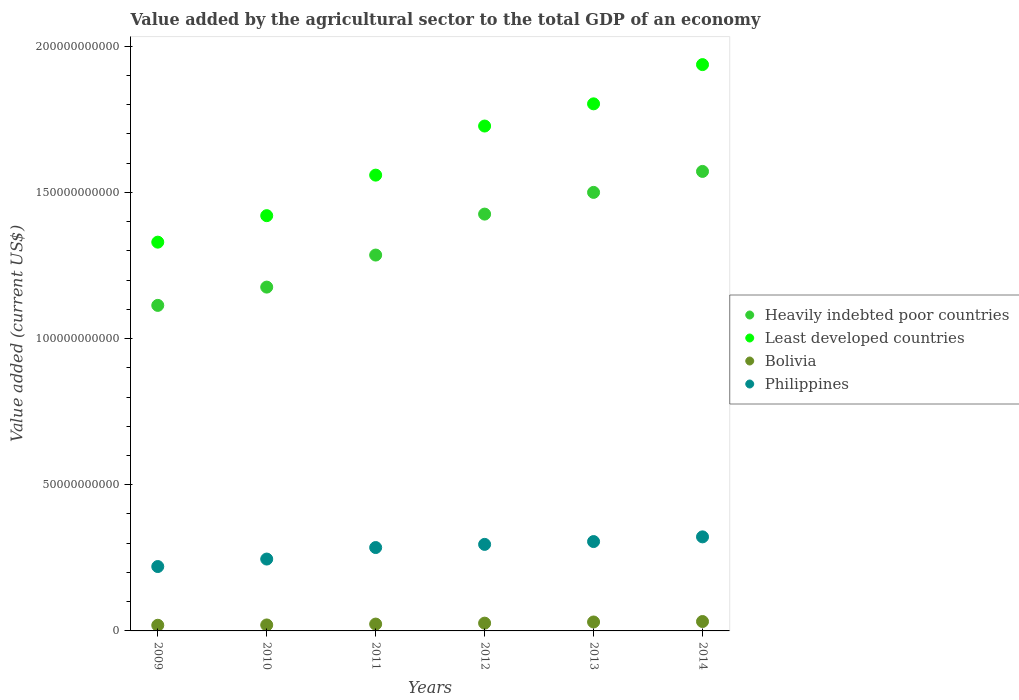How many different coloured dotlines are there?
Your response must be concise. 4. What is the value added by the agricultural sector to the total GDP in Bolivia in 2014?
Your response must be concise. 3.21e+09. Across all years, what is the maximum value added by the agricultural sector to the total GDP in Heavily indebted poor countries?
Your answer should be very brief. 1.57e+11. Across all years, what is the minimum value added by the agricultural sector to the total GDP in Bolivia?
Make the answer very short. 1.93e+09. In which year was the value added by the agricultural sector to the total GDP in Bolivia minimum?
Make the answer very short. 2009. What is the total value added by the agricultural sector to the total GDP in Bolivia in the graph?
Your answer should be very brief. 1.52e+1. What is the difference between the value added by the agricultural sector to the total GDP in Philippines in 2013 and that in 2014?
Keep it short and to the point. -1.61e+09. What is the difference between the value added by the agricultural sector to the total GDP in Heavily indebted poor countries in 2011 and the value added by the agricultural sector to the total GDP in Bolivia in 2012?
Your answer should be compact. 1.26e+11. What is the average value added by the agricultural sector to the total GDP in Heavily indebted poor countries per year?
Provide a short and direct response. 1.35e+11. In the year 2009, what is the difference between the value added by the agricultural sector to the total GDP in Least developed countries and value added by the agricultural sector to the total GDP in Heavily indebted poor countries?
Make the answer very short. 2.16e+1. In how many years, is the value added by the agricultural sector to the total GDP in Heavily indebted poor countries greater than 130000000000 US$?
Make the answer very short. 3. What is the ratio of the value added by the agricultural sector to the total GDP in Philippines in 2012 to that in 2014?
Offer a terse response. 0.92. Is the value added by the agricultural sector to the total GDP in Least developed countries in 2009 less than that in 2012?
Ensure brevity in your answer.  Yes. What is the difference between the highest and the second highest value added by the agricultural sector to the total GDP in Bolivia?
Provide a succinct answer. 1.58e+08. What is the difference between the highest and the lowest value added by the agricultural sector to the total GDP in Least developed countries?
Provide a succinct answer. 6.07e+1. Is it the case that in every year, the sum of the value added by the agricultural sector to the total GDP in Least developed countries and value added by the agricultural sector to the total GDP in Bolivia  is greater than the sum of value added by the agricultural sector to the total GDP in Heavily indebted poor countries and value added by the agricultural sector to the total GDP in Philippines?
Ensure brevity in your answer.  No. Is the value added by the agricultural sector to the total GDP in Least developed countries strictly greater than the value added by the agricultural sector to the total GDP in Heavily indebted poor countries over the years?
Ensure brevity in your answer.  Yes. Is the value added by the agricultural sector to the total GDP in Least developed countries strictly less than the value added by the agricultural sector to the total GDP in Philippines over the years?
Offer a very short reply. No. How many years are there in the graph?
Provide a short and direct response. 6. What is the difference between two consecutive major ticks on the Y-axis?
Give a very brief answer. 5.00e+1. Are the values on the major ticks of Y-axis written in scientific E-notation?
Provide a short and direct response. No. Does the graph contain any zero values?
Your response must be concise. No. How many legend labels are there?
Provide a short and direct response. 4. How are the legend labels stacked?
Offer a very short reply. Vertical. What is the title of the graph?
Offer a very short reply. Value added by the agricultural sector to the total GDP of an economy. Does "West Bank and Gaza" appear as one of the legend labels in the graph?
Offer a terse response. No. What is the label or title of the Y-axis?
Offer a very short reply. Value added (current US$). What is the Value added (current US$) in Heavily indebted poor countries in 2009?
Offer a terse response. 1.11e+11. What is the Value added (current US$) of Least developed countries in 2009?
Your response must be concise. 1.33e+11. What is the Value added (current US$) in Bolivia in 2009?
Give a very brief answer. 1.93e+09. What is the Value added (current US$) in Philippines in 2009?
Your answer should be compact. 2.20e+1. What is the Value added (current US$) in Heavily indebted poor countries in 2010?
Provide a succinct answer. 1.18e+11. What is the Value added (current US$) in Least developed countries in 2010?
Keep it short and to the point. 1.42e+11. What is the Value added (current US$) of Bolivia in 2010?
Provide a short and direct response. 2.04e+09. What is the Value added (current US$) in Philippines in 2010?
Your answer should be very brief. 2.46e+1. What is the Value added (current US$) of Heavily indebted poor countries in 2011?
Offer a very short reply. 1.29e+11. What is the Value added (current US$) of Least developed countries in 2011?
Your response must be concise. 1.56e+11. What is the Value added (current US$) of Bolivia in 2011?
Make the answer very short. 2.34e+09. What is the Value added (current US$) of Philippines in 2011?
Offer a terse response. 2.85e+1. What is the Value added (current US$) in Heavily indebted poor countries in 2012?
Keep it short and to the point. 1.43e+11. What is the Value added (current US$) of Least developed countries in 2012?
Provide a succinct answer. 1.73e+11. What is the Value added (current US$) in Bolivia in 2012?
Your answer should be very brief. 2.66e+09. What is the Value added (current US$) of Philippines in 2012?
Your answer should be very brief. 2.96e+1. What is the Value added (current US$) in Heavily indebted poor countries in 2013?
Make the answer very short. 1.50e+11. What is the Value added (current US$) of Least developed countries in 2013?
Keep it short and to the point. 1.80e+11. What is the Value added (current US$) of Bolivia in 2013?
Provide a succinct answer. 3.06e+09. What is the Value added (current US$) of Philippines in 2013?
Ensure brevity in your answer.  3.06e+1. What is the Value added (current US$) of Heavily indebted poor countries in 2014?
Provide a succinct answer. 1.57e+11. What is the Value added (current US$) in Least developed countries in 2014?
Your answer should be compact. 1.94e+11. What is the Value added (current US$) in Bolivia in 2014?
Your answer should be compact. 3.21e+09. What is the Value added (current US$) of Philippines in 2014?
Provide a short and direct response. 3.22e+1. Across all years, what is the maximum Value added (current US$) of Heavily indebted poor countries?
Keep it short and to the point. 1.57e+11. Across all years, what is the maximum Value added (current US$) in Least developed countries?
Give a very brief answer. 1.94e+11. Across all years, what is the maximum Value added (current US$) of Bolivia?
Make the answer very short. 3.21e+09. Across all years, what is the maximum Value added (current US$) in Philippines?
Give a very brief answer. 3.22e+1. Across all years, what is the minimum Value added (current US$) in Heavily indebted poor countries?
Make the answer very short. 1.11e+11. Across all years, what is the minimum Value added (current US$) in Least developed countries?
Your response must be concise. 1.33e+11. Across all years, what is the minimum Value added (current US$) of Bolivia?
Provide a short and direct response. 1.93e+09. Across all years, what is the minimum Value added (current US$) in Philippines?
Your answer should be compact. 2.20e+1. What is the total Value added (current US$) of Heavily indebted poor countries in the graph?
Your response must be concise. 8.07e+11. What is the total Value added (current US$) of Least developed countries in the graph?
Provide a succinct answer. 9.77e+11. What is the total Value added (current US$) in Bolivia in the graph?
Ensure brevity in your answer.  1.52e+1. What is the total Value added (current US$) in Philippines in the graph?
Your answer should be very brief. 1.67e+11. What is the difference between the Value added (current US$) in Heavily indebted poor countries in 2009 and that in 2010?
Give a very brief answer. -6.25e+09. What is the difference between the Value added (current US$) of Least developed countries in 2009 and that in 2010?
Provide a short and direct response. -9.06e+09. What is the difference between the Value added (current US$) of Bolivia in 2009 and that in 2010?
Offer a very short reply. -1.08e+08. What is the difference between the Value added (current US$) in Philippines in 2009 and that in 2010?
Make the answer very short. -2.56e+09. What is the difference between the Value added (current US$) in Heavily indebted poor countries in 2009 and that in 2011?
Your answer should be very brief. -1.72e+1. What is the difference between the Value added (current US$) in Least developed countries in 2009 and that in 2011?
Your response must be concise. -2.29e+1. What is the difference between the Value added (current US$) of Bolivia in 2009 and that in 2011?
Give a very brief answer. -4.07e+08. What is the difference between the Value added (current US$) in Philippines in 2009 and that in 2011?
Ensure brevity in your answer.  -6.49e+09. What is the difference between the Value added (current US$) of Heavily indebted poor countries in 2009 and that in 2012?
Keep it short and to the point. -3.12e+1. What is the difference between the Value added (current US$) of Least developed countries in 2009 and that in 2012?
Give a very brief answer. -3.97e+1. What is the difference between the Value added (current US$) in Bolivia in 2009 and that in 2012?
Keep it short and to the point. -7.24e+08. What is the difference between the Value added (current US$) in Philippines in 2009 and that in 2012?
Offer a terse response. -7.58e+09. What is the difference between the Value added (current US$) of Heavily indebted poor countries in 2009 and that in 2013?
Make the answer very short. -3.86e+1. What is the difference between the Value added (current US$) in Least developed countries in 2009 and that in 2013?
Ensure brevity in your answer.  -4.73e+1. What is the difference between the Value added (current US$) of Bolivia in 2009 and that in 2013?
Give a very brief answer. -1.12e+09. What is the difference between the Value added (current US$) of Philippines in 2009 and that in 2013?
Provide a succinct answer. -8.54e+09. What is the difference between the Value added (current US$) in Heavily indebted poor countries in 2009 and that in 2014?
Ensure brevity in your answer.  -4.58e+1. What is the difference between the Value added (current US$) of Least developed countries in 2009 and that in 2014?
Offer a very short reply. -6.07e+1. What is the difference between the Value added (current US$) in Bolivia in 2009 and that in 2014?
Provide a short and direct response. -1.28e+09. What is the difference between the Value added (current US$) in Philippines in 2009 and that in 2014?
Give a very brief answer. -1.01e+1. What is the difference between the Value added (current US$) in Heavily indebted poor countries in 2010 and that in 2011?
Provide a short and direct response. -1.10e+1. What is the difference between the Value added (current US$) in Least developed countries in 2010 and that in 2011?
Your answer should be very brief. -1.39e+1. What is the difference between the Value added (current US$) of Bolivia in 2010 and that in 2011?
Ensure brevity in your answer.  -3.00e+08. What is the difference between the Value added (current US$) in Philippines in 2010 and that in 2011?
Give a very brief answer. -3.94e+09. What is the difference between the Value added (current US$) of Heavily indebted poor countries in 2010 and that in 2012?
Your response must be concise. -2.50e+1. What is the difference between the Value added (current US$) of Least developed countries in 2010 and that in 2012?
Your answer should be compact. -3.07e+1. What is the difference between the Value added (current US$) in Bolivia in 2010 and that in 2012?
Provide a succinct answer. -6.16e+08. What is the difference between the Value added (current US$) of Philippines in 2010 and that in 2012?
Your answer should be very brief. -5.02e+09. What is the difference between the Value added (current US$) of Heavily indebted poor countries in 2010 and that in 2013?
Give a very brief answer. -3.24e+1. What is the difference between the Value added (current US$) in Least developed countries in 2010 and that in 2013?
Make the answer very short. -3.82e+1. What is the difference between the Value added (current US$) of Bolivia in 2010 and that in 2013?
Your response must be concise. -1.01e+09. What is the difference between the Value added (current US$) in Philippines in 2010 and that in 2013?
Make the answer very short. -5.98e+09. What is the difference between the Value added (current US$) of Heavily indebted poor countries in 2010 and that in 2014?
Offer a very short reply. -3.96e+1. What is the difference between the Value added (current US$) of Least developed countries in 2010 and that in 2014?
Provide a succinct answer. -5.17e+1. What is the difference between the Value added (current US$) in Bolivia in 2010 and that in 2014?
Your response must be concise. -1.17e+09. What is the difference between the Value added (current US$) in Philippines in 2010 and that in 2014?
Ensure brevity in your answer.  -7.59e+09. What is the difference between the Value added (current US$) in Heavily indebted poor countries in 2011 and that in 2012?
Provide a succinct answer. -1.40e+1. What is the difference between the Value added (current US$) of Least developed countries in 2011 and that in 2012?
Keep it short and to the point. -1.68e+1. What is the difference between the Value added (current US$) in Bolivia in 2011 and that in 2012?
Make the answer very short. -3.16e+08. What is the difference between the Value added (current US$) in Philippines in 2011 and that in 2012?
Ensure brevity in your answer.  -1.08e+09. What is the difference between the Value added (current US$) in Heavily indebted poor countries in 2011 and that in 2013?
Ensure brevity in your answer.  -2.14e+1. What is the difference between the Value added (current US$) of Least developed countries in 2011 and that in 2013?
Keep it short and to the point. -2.44e+1. What is the difference between the Value added (current US$) in Bolivia in 2011 and that in 2013?
Offer a terse response. -7.15e+08. What is the difference between the Value added (current US$) of Philippines in 2011 and that in 2013?
Offer a very short reply. -2.05e+09. What is the difference between the Value added (current US$) in Heavily indebted poor countries in 2011 and that in 2014?
Ensure brevity in your answer.  -2.86e+1. What is the difference between the Value added (current US$) in Least developed countries in 2011 and that in 2014?
Your response must be concise. -3.78e+1. What is the difference between the Value added (current US$) of Bolivia in 2011 and that in 2014?
Keep it short and to the point. -8.73e+08. What is the difference between the Value added (current US$) in Philippines in 2011 and that in 2014?
Your response must be concise. -3.66e+09. What is the difference between the Value added (current US$) of Heavily indebted poor countries in 2012 and that in 2013?
Your answer should be compact. -7.43e+09. What is the difference between the Value added (current US$) in Least developed countries in 2012 and that in 2013?
Make the answer very short. -7.59e+09. What is the difference between the Value added (current US$) of Bolivia in 2012 and that in 2013?
Provide a succinct answer. -3.98e+08. What is the difference between the Value added (current US$) of Philippines in 2012 and that in 2013?
Your answer should be compact. -9.65e+08. What is the difference between the Value added (current US$) in Heavily indebted poor countries in 2012 and that in 2014?
Give a very brief answer. -1.46e+1. What is the difference between the Value added (current US$) of Least developed countries in 2012 and that in 2014?
Your response must be concise. -2.10e+1. What is the difference between the Value added (current US$) of Bolivia in 2012 and that in 2014?
Give a very brief answer. -5.56e+08. What is the difference between the Value added (current US$) of Philippines in 2012 and that in 2014?
Offer a terse response. -2.57e+09. What is the difference between the Value added (current US$) in Heavily indebted poor countries in 2013 and that in 2014?
Offer a very short reply. -7.17e+09. What is the difference between the Value added (current US$) in Least developed countries in 2013 and that in 2014?
Your response must be concise. -1.34e+1. What is the difference between the Value added (current US$) of Bolivia in 2013 and that in 2014?
Provide a succinct answer. -1.58e+08. What is the difference between the Value added (current US$) in Philippines in 2013 and that in 2014?
Give a very brief answer. -1.61e+09. What is the difference between the Value added (current US$) of Heavily indebted poor countries in 2009 and the Value added (current US$) of Least developed countries in 2010?
Your answer should be very brief. -3.07e+1. What is the difference between the Value added (current US$) of Heavily indebted poor countries in 2009 and the Value added (current US$) of Bolivia in 2010?
Make the answer very short. 1.09e+11. What is the difference between the Value added (current US$) of Heavily indebted poor countries in 2009 and the Value added (current US$) of Philippines in 2010?
Give a very brief answer. 8.68e+1. What is the difference between the Value added (current US$) of Least developed countries in 2009 and the Value added (current US$) of Bolivia in 2010?
Provide a short and direct response. 1.31e+11. What is the difference between the Value added (current US$) of Least developed countries in 2009 and the Value added (current US$) of Philippines in 2010?
Offer a very short reply. 1.08e+11. What is the difference between the Value added (current US$) in Bolivia in 2009 and the Value added (current US$) in Philippines in 2010?
Your answer should be very brief. -2.26e+1. What is the difference between the Value added (current US$) in Heavily indebted poor countries in 2009 and the Value added (current US$) in Least developed countries in 2011?
Your answer should be very brief. -4.45e+1. What is the difference between the Value added (current US$) of Heavily indebted poor countries in 2009 and the Value added (current US$) of Bolivia in 2011?
Provide a short and direct response. 1.09e+11. What is the difference between the Value added (current US$) of Heavily indebted poor countries in 2009 and the Value added (current US$) of Philippines in 2011?
Ensure brevity in your answer.  8.28e+1. What is the difference between the Value added (current US$) of Least developed countries in 2009 and the Value added (current US$) of Bolivia in 2011?
Give a very brief answer. 1.31e+11. What is the difference between the Value added (current US$) in Least developed countries in 2009 and the Value added (current US$) in Philippines in 2011?
Your answer should be very brief. 1.04e+11. What is the difference between the Value added (current US$) in Bolivia in 2009 and the Value added (current US$) in Philippines in 2011?
Provide a succinct answer. -2.66e+1. What is the difference between the Value added (current US$) in Heavily indebted poor countries in 2009 and the Value added (current US$) in Least developed countries in 2012?
Provide a short and direct response. -6.13e+1. What is the difference between the Value added (current US$) of Heavily indebted poor countries in 2009 and the Value added (current US$) of Bolivia in 2012?
Ensure brevity in your answer.  1.09e+11. What is the difference between the Value added (current US$) of Heavily indebted poor countries in 2009 and the Value added (current US$) of Philippines in 2012?
Ensure brevity in your answer.  8.17e+1. What is the difference between the Value added (current US$) in Least developed countries in 2009 and the Value added (current US$) in Bolivia in 2012?
Your answer should be very brief. 1.30e+11. What is the difference between the Value added (current US$) of Least developed countries in 2009 and the Value added (current US$) of Philippines in 2012?
Your answer should be very brief. 1.03e+11. What is the difference between the Value added (current US$) of Bolivia in 2009 and the Value added (current US$) of Philippines in 2012?
Offer a terse response. -2.77e+1. What is the difference between the Value added (current US$) in Heavily indebted poor countries in 2009 and the Value added (current US$) in Least developed countries in 2013?
Offer a terse response. -6.89e+1. What is the difference between the Value added (current US$) of Heavily indebted poor countries in 2009 and the Value added (current US$) of Bolivia in 2013?
Provide a succinct answer. 1.08e+11. What is the difference between the Value added (current US$) of Heavily indebted poor countries in 2009 and the Value added (current US$) of Philippines in 2013?
Offer a very short reply. 8.08e+1. What is the difference between the Value added (current US$) in Least developed countries in 2009 and the Value added (current US$) in Bolivia in 2013?
Give a very brief answer. 1.30e+11. What is the difference between the Value added (current US$) of Least developed countries in 2009 and the Value added (current US$) of Philippines in 2013?
Keep it short and to the point. 1.02e+11. What is the difference between the Value added (current US$) of Bolivia in 2009 and the Value added (current US$) of Philippines in 2013?
Ensure brevity in your answer.  -2.86e+1. What is the difference between the Value added (current US$) of Heavily indebted poor countries in 2009 and the Value added (current US$) of Least developed countries in 2014?
Ensure brevity in your answer.  -8.23e+1. What is the difference between the Value added (current US$) in Heavily indebted poor countries in 2009 and the Value added (current US$) in Bolivia in 2014?
Provide a succinct answer. 1.08e+11. What is the difference between the Value added (current US$) in Heavily indebted poor countries in 2009 and the Value added (current US$) in Philippines in 2014?
Give a very brief answer. 7.92e+1. What is the difference between the Value added (current US$) of Least developed countries in 2009 and the Value added (current US$) of Bolivia in 2014?
Give a very brief answer. 1.30e+11. What is the difference between the Value added (current US$) of Least developed countries in 2009 and the Value added (current US$) of Philippines in 2014?
Keep it short and to the point. 1.01e+11. What is the difference between the Value added (current US$) of Bolivia in 2009 and the Value added (current US$) of Philippines in 2014?
Offer a very short reply. -3.02e+1. What is the difference between the Value added (current US$) in Heavily indebted poor countries in 2010 and the Value added (current US$) in Least developed countries in 2011?
Ensure brevity in your answer.  -3.83e+1. What is the difference between the Value added (current US$) of Heavily indebted poor countries in 2010 and the Value added (current US$) of Bolivia in 2011?
Keep it short and to the point. 1.15e+11. What is the difference between the Value added (current US$) of Heavily indebted poor countries in 2010 and the Value added (current US$) of Philippines in 2011?
Provide a succinct answer. 8.91e+1. What is the difference between the Value added (current US$) in Least developed countries in 2010 and the Value added (current US$) in Bolivia in 2011?
Keep it short and to the point. 1.40e+11. What is the difference between the Value added (current US$) in Least developed countries in 2010 and the Value added (current US$) in Philippines in 2011?
Your answer should be compact. 1.14e+11. What is the difference between the Value added (current US$) in Bolivia in 2010 and the Value added (current US$) in Philippines in 2011?
Your answer should be compact. -2.65e+1. What is the difference between the Value added (current US$) in Heavily indebted poor countries in 2010 and the Value added (current US$) in Least developed countries in 2012?
Offer a terse response. -5.51e+1. What is the difference between the Value added (current US$) of Heavily indebted poor countries in 2010 and the Value added (current US$) of Bolivia in 2012?
Make the answer very short. 1.15e+11. What is the difference between the Value added (current US$) of Heavily indebted poor countries in 2010 and the Value added (current US$) of Philippines in 2012?
Your answer should be compact. 8.80e+1. What is the difference between the Value added (current US$) of Least developed countries in 2010 and the Value added (current US$) of Bolivia in 2012?
Offer a terse response. 1.39e+11. What is the difference between the Value added (current US$) of Least developed countries in 2010 and the Value added (current US$) of Philippines in 2012?
Offer a terse response. 1.12e+11. What is the difference between the Value added (current US$) in Bolivia in 2010 and the Value added (current US$) in Philippines in 2012?
Your answer should be very brief. -2.76e+1. What is the difference between the Value added (current US$) in Heavily indebted poor countries in 2010 and the Value added (current US$) in Least developed countries in 2013?
Make the answer very short. -6.27e+1. What is the difference between the Value added (current US$) in Heavily indebted poor countries in 2010 and the Value added (current US$) in Bolivia in 2013?
Make the answer very short. 1.15e+11. What is the difference between the Value added (current US$) in Heavily indebted poor countries in 2010 and the Value added (current US$) in Philippines in 2013?
Provide a succinct answer. 8.70e+1. What is the difference between the Value added (current US$) in Least developed countries in 2010 and the Value added (current US$) in Bolivia in 2013?
Ensure brevity in your answer.  1.39e+11. What is the difference between the Value added (current US$) of Least developed countries in 2010 and the Value added (current US$) of Philippines in 2013?
Provide a short and direct response. 1.11e+11. What is the difference between the Value added (current US$) of Bolivia in 2010 and the Value added (current US$) of Philippines in 2013?
Keep it short and to the point. -2.85e+1. What is the difference between the Value added (current US$) of Heavily indebted poor countries in 2010 and the Value added (current US$) of Least developed countries in 2014?
Give a very brief answer. -7.61e+1. What is the difference between the Value added (current US$) of Heavily indebted poor countries in 2010 and the Value added (current US$) of Bolivia in 2014?
Give a very brief answer. 1.14e+11. What is the difference between the Value added (current US$) in Heavily indebted poor countries in 2010 and the Value added (current US$) in Philippines in 2014?
Keep it short and to the point. 8.54e+1. What is the difference between the Value added (current US$) of Least developed countries in 2010 and the Value added (current US$) of Bolivia in 2014?
Your answer should be very brief. 1.39e+11. What is the difference between the Value added (current US$) of Least developed countries in 2010 and the Value added (current US$) of Philippines in 2014?
Keep it short and to the point. 1.10e+11. What is the difference between the Value added (current US$) of Bolivia in 2010 and the Value added (current US$) of Philippines in 2014?
Provide a succinct answer. -3.01e+1. What is the difference between the Value added (current US$) of Heavily indebted poor countries in 2011 and the Value added (current US$) of Least developed countries in 2012?
Give a very brief answer. -4.41e+1. What is the difference between the Value added (current US$) in Heavily indebted poor countries in 2011 and the Value added (current US$) in Bolivia in 2012?
Offer a very short reply. 1.26e+11. What is the difference between the Value added (current US$) of Heavily indebted poor countries in 2011 and the Value added (current US$) of Philippines in 2012?
Your response must be concise. 9.90e+1. What is the difference between the Value added (current US$) of Least developed countries in 2011 and the Value added (current US$) of Bolivia in 2012?
Ensure brevity in your answer.  1.53e+11. What is the difference between the Value added (current US$) in Least developed countries in 2011 and the Value added (current US$) in Philippines in 2012?
Give a very brief answer. 1.26e+11. What is the difference between the Value added (current US$) of Bolivia in 2011 and the Value added (current US$) of Philippines in 2012?
Ensure brevity in your answer.  -2.73e+1. What is the difference between the Value added (current US$) in Heavily indebted poor countries in 2011 and the Value added (current US$) in Least developed countries in 2013?
Your response must be concise. -5.17e+1. What is the difference between the Value added (current US$) of Heavily indebted poor countries in 2011 and the Value added (current US$) of Bolivia in 2013?
Provide a succinct answer. 1.25e+11. What is the difference between the Value added (current US$) of Heavily indebted poor countries in 2011 and the Value added (current US$) of Philippines in 2013?
Your answer should be compact. 9.80e+1. What is the difference between the Value added (current US$) of Least developed countries in 2011 and the Value added (current US$) of Bolivia in 2013?
Keep it short and to the point. 1.53e+11. What is the difference between the Value added (current US$) of Least developed countries in 2011 and the Value added (current US$) of Philippines in 2013?
Offer a very short reply. 1.25e+11. What is the difference between the Value added (current US$) in Bolivia in 2011 and the Value added (current US$) in Philippines in 2013?
Provide a short and direct response. -2.82e+1. What is the difference between the Value added (current US$) in Heavily indebted poor countries in 2011 and the Value added (current US$) in Least developed countries in 2014?
Your response must be concise. -6.51e+1. What is the difference between the Value added (current US$) in Heavily indebted poor countries in 2011 and the Value added (current US$) in Bolivia in 2014?
Give a very brief answer. 1.25e+11. What is the difference between the Value added (current US$) of Heavily indebted poor countries in 2011 and the Value added (current US$) of Philippines in 2014?
Keep it short and to the point. 9.64e+1. What is the difference between the Value added (current US$) in Least developed countries in 2011 and the Value added (current US$) in Bolivia in 2014?
Your response must be concise. 1.53e+11. What is the difference between the Value added (current US$) in Least developed countries in 2011 and the Value added (current US$) in Philippines in 2014?
Keep it short and to the point. 1.24e+11. What is the difference between the Value added (current US$) of Bolivia in 2011 and the Value added (current US$) of Philippines in 2014?
Provide a short and direct response. -2.98e+1. What is the difference between the Value added (current US$) in Heavily indebted poor countries in 2012 and the Value added (current US$) in Least developed countries in 2013?
Your answer should be very brief. -3.77e+1. What is the difference between the Value added (current US$) in Heavily indebted poor countries in 2012 and the Value added (current US$) in Bolivia in 2013?
Your response must be concise. 1.39e+11. What is the difference between the Value added (current US$) of Heavily indebted poor countries in 2012 and the Value added (current US$) of Philippines in 2013?
Keep it short and to the point. 1.12e+11. What is the difference between the Value added (current US$) of Least developed countries in 2012 and the Value added (current US$) of Bolivia in 2013?
Your answer should be compact. 1.70e+11. What is the difference between the Value added (current US$) of Least developed countries in 2012 and the Value added (current US$) of Philippines in 2013?
Your response must be concise. 1.42e+11. What is the difference between the Value added (current US$) in Bolivia in 2012 and the Value added (current US$) in Philippines in 2013?
Your answer should be very brief. -2.79e+1. What is the difference between the Value added (current US$) of Heavily indebted poor countries in 2012 and the Value added (current US$) of Least developed countries in 2014?
Provide a short and direct response. -5.11e+1. What is the difference between the Value added (current US$) of Heavily indebted poor countries in 2012 and the Value added (current US$) of Bolivia in 2014?
Provide a short and direct response. 1.39e+11. What is the difference between the Value added (current US$) of Heavily indebted poor countries in 2012 and the Value added (current US$) of Philippines in 2014?
Give a very brief answer. 1.10e+11. What is the difference between the Value added (current US$) in Least developed countries in 2012 and the Value added (current US$) in Bolivia in 2014?
Ensure brevity in your answer.  1.69e+11. What is the difference between the Value added (current US$) in Least developed countries in 2012 and the Value added (current US$) in Philippines in 2014?
Ensure brevity in your answer.  1.41e+11. What is the difference between the Value added (current US$) of Bolivia in 2012 and the Value added (current US$) of Philippines in 2014?
Provide a succinct answer. -2.95e+1. What is the difference between the Value added (current US$) in Heavily indebted poor countries in 2013 and the Value added (current US$) in Least developed countries in 2014?
Your answer should be very brief. -4.37e+1. What is the difference between the Value added (current US$) in Heavily indebted poor countries in 2013 and the Value added (current US$) in Bolivia in 2014?
Provide a succinct answer. 1.47e+11. What is the difference between the Value added (current US$) of Heavily indebted poor countries in 2013 and the Value added (current US$) of Philippines in 2014?
Offer a very short reply. 1.18e+11. What is the difference between the Value added (current US$) of Least developed countries in 2013 and the Value added (current US$) of Bolivia in 2014?
Keep it short and to the point. 1.77e+11. What is the difference between the Value added (current US$) in Least developed countries in 2013 and the Value added (current US$) in Philippines in 2014?
Give a very brief answer. 1.48e+11. What is the difference between the Value added (current US$) in Bolivia in 2013 and the Value added (current US$) in Philippines in 2014?
Provide a short and direct response. -2.91e+1. What is the average Value added (current US$) in Heavily indebted poor countries per year?
Provide a succinct answer. 1.35e+11. What is the average Value added (current US$) in Least developed countries per year?
Offer a very short reply. 1.63e+11. What is the average Value added (current US$) of Bolivia per year?
Keep it short and to the point. 2.54e+09. What is the average Value added (current US$) of Philippines per year?
Offer a very short reply. 2.79e+1. In the year 2009, what is the difference between the Value added (current US$) of Heavily indebted poor countries and Value added (current US$) of Least developed countries?
Your answer should be compact. -2.16e+1. In the year 2009, what is the difference between the Value added (current US$) of Heavily indebted poor countries and Value added (current US$) of Bolivia?
Your answer should be compact. 1.09e+11. In the year 2009, what is the difference between the Value added (current US$) in Heavily indebted poor countries and Value added (current US$) in Philippines?
Make the answer very short. 8.93e+1. In the year 2009, what is the difference between the Value added (current US$) of Least developed countries and Value added (current US$) of Bolivia?
Your answer should be very brief. 1.31e+11. In the year 2009, what is the difference between the Value added (current US$) in Least developed countries and Value added (current US$) in Philippines?
Provide a short and direct response. 1.11e+11. In the year 2009, what is the difference between the Value added (current US$) in Bolivia and Value added (current US$) in Philippines?
Make the answer very short. -2.01e+1. In the year 2010, what is the difference between the Value added (current US$) in Heavily indebted poor countries and Value added (current US$) in Least developed countries?
Your response must be concise. -2.44e+1. In the year 2010, what is the difference between the Value added (current US$) of Heavily indebted poor countries and Value added (current US$) of Bolivia?
Your answer should be very brief. 1.16e+11. In the year 2010, what is the difference between the Value added (current US$) in Heavily indebted poor countries and Value added (current US$) in Philippines?
Give a very brief answer. 9.30e+1. In the year 2010, what is the difference between the Value added (current US$) in Least developed countries and Value added (current US$) in Bolivia?
Your response must be concise. 1.40e+11. In the year 2010, what is the difference between the Value added (current US$) of Least developed countries and Value added (current US$) of Philippines?
Provide a succinct answer. 1.17e+11. In the year 2010, what is the difference between the Value added (current US$) in Bolivia and Value added (current US$) in Philippines?
Your answer should be very brief. -2.25e+1. In the year 2011, what is the difference between the Value added (current US$) in Heavily indebted poor countries and Value added (current US$) in Least developed countries?
Give a very brief answer. -2.73e+1. In the year 2011, what is the difference between the Value added (current US$) of Heavily indebted poor countries and Value added (current US$) of Bolivia?
Make the answer very short. 1.26e+11. In the year 2011, what is the difference between the Value added (current US$) of Heavily indebted poor countries and Value added (current US$) of Philippines?
Provide a short and direct response. 1.00e+11. In the year 2011, what is the difference between the Value added (current US$) of Least developed countries and Value added (current US$) of Bolivia?
Your answer should be very brief. 1.54e+11. In the year 2011, what is the difference between the Value added (current US$) of Least developed countries and Value added (current US$) of Philippines?
Make the answer very short. 1.27e+11. In the year 2011, what is the difference between the Value added (current US$) in Bolivia and Value added (current US$) in Philippines?
Offer a very short reply. -2.62e+1. In the year 2012, what is the difference between the Value added (current US$) of Heavily indebted poor countries and Value added (current US$) of Least developed countries?
Your response must be concise. -3.01e+1. In the year 2012, what is the difference between the Value added (current US$) in Heavily indebted poor countries and Value added (current US$) in Bolivia?
Give a very brief answer. 1.40e+11. In the year 2012, what is the difference between the Value added (current US$) of Heavily indebted poor countries and Value added (current US$) of Philippines?
Ensure brevity in your answer.  1.13e+11. In the year 2012, what is the difference between the Value added (current US$) of Least developed countries and Value added (current US$) of Bolivia?
Your answer should be very brief. 1.70e+11. In the year 2012, what is the difference between the Value added (current US$) of Least developed countries and Value added (current US$) of Philippines?
Your answer should be very brief. 1.43e+11. In the year 2012, what is the difference between the Value added (current US$) in Bolivia and Value added (current US$) in Philippines?
Offer a very short reply. -2.69e+1. In the year 2013, what is the difference between the Value added (current US$) of Heavily indebted poor countries and Value added (current US$) of Least developed countries?
Offer a very short reply. -3.03e+1. In the year 2013, what is the difference between the Value added (current US$) of Heavily indebted poor countries and Value added (current US$) of Bolivia?
Provide a short and direct response. 1.47e+11. In the year 2013, what is the difference between the Value added (current US$) in Heavily indebted poor countries and Value added (current US$) in Philippines?
Offer a very short reply. 1.19e+11. In the year 2013, what is the difference between the Value added (current US$) in Least developed countries and Value added (current US$) in Bolivia?
Your answer should be very brief. 1.77e+11. In the year 2013, what is the difference between the Value added (current US$) of Least developed countries and Value added (current US$) of Philippines?
Give a very brief answer. 1.50e+11. In the year 2013, what is the difference between the Value added (current US$) in Bolivia and Value added (current US$) in Philippines?
Ensure brevity in your answer.  -2.75e+1. In the year 2014, what is the difference between the Value added (current US$) of Heavily indebted poor countries and Value added (current US$) of Least developed countries?
Offer a very short reply. -3.65e+1. In the year 2014, what is the difference between the Value added (current US$) in Heavily indebted poor countries and Value added (current US$) in Bolivia?
Your answer should be compact. 1.54e+11. In the year 2014, what is the difference between the Value added (current US$) in Heavily indebted poor countries and Value added (current US$) in Philippines?
Your answer should be compact. 1.25e+11. In the year 2014, what is the difference between the Value added (current US$) of Least developed countries and Value added (current US$) of Bolivia?
Offer a very short reply. 1.90e+11. In the year 2014, what is the difference between the Value added (current US$) in Least developed countries and Value added (current US$) in Philippines?
Give a very brief answer. 1.62e+11. In the year 2014, what is the difference between the Value added (current US$) of Bolivia and Value added (current US$) of Philippines?
Your answer should be compact. -2.90e+1. What is the ratio of the Value added (current US$) of Heavily indebted poor countries in 2009 to that in 2010?
Your answer should be very brief. 0.95. What is the ratio of the Value added (current US$) of Least developed countries in 2009 to that in 2010?
Offer a very short reply. 0.94. What is the ratio of the Value added (current US$) of Bolivia in 2009 to that in 2010?
Provide a succinct answer. 0.95. What is the ratio of the Value added (current US$) of Philippines in 2009 to that in 2010?
Provide a short and direct response. 0.9. What is the ratio of the Value added (current US$) in Heavily indebted poor countries in 2009 to that in 2011?
Make the answer very short. 0.87. What is the ratio of the Value added (current US$) of Least developed countries in 2009 to that in 2011?
Your answer should be compact. 0.85. What is the ratio of the Value added (current US$) of Bolivia in 2009 to that in 2011?
Provide a short and direct response. 0.83. What is the ratio of the Value added (current US$) in Philippines in 2009 to that in 2011?
Your answer should be very brief. 0.77. What is the ratio of the Value added (current US$) in Heavily indebted poor countries in 2009 to that in 2012?
Your response must be concise. 0.78. What is the ratio of the Value added (current US$) in Least developed countries in 2009 to that in 2012?
Make the answer very short. 0.77. What is the ratio of the Value added (current US$) in Bolivia in 2009 to that in 2012?
Your answer should be compact. 0.73. What is the ratio of the Value added (current US$) in Philippines in 2009 to that in 2012?
Provide a succinct answer. 0.74. What is the ratio of the Value added (current US$) in Heavily indebted poor countries in 2009 to that in 2013?
Offer a terse response. 0.74. What is the ratio of the Value added (current US$) in Least developed countries in 2009 to that in 2013?
Provide a short and direct response. 0.74. What is the ratio of the Value added (current US$) in Bolivia in 2009 to that in 2013?
Offer a terse response. 0.63. What is the ratio of the Value added (current US$) in Philippines in 2009 to that in 2013?
Provide a succinct answer. 0.72. What is the ratio of the Value added (current US$) of Heavily indebted poor countries in 2009 to that in 2014?
Your response must be concise. 0.71. What is the ratio of the Value added (current US$) in Least developed countries in 2009 to that in 2014?
Provide a succinct answer. 0.69. What is the ratio of the Value added (current US$) in Bolivia in 2009 to that in 2014?
Your response must be concise. 0.6. What is the ratio of the Value added (current US$) in Philippines in 2009 to that in 2014?
Make the answer very short. 0.68. What is the ratio of the Value added (current US$) in Heavily indebted poor countries in 2010 to that in 2011?
Keep it short and to the point. 0.91. What is the ratio of the Value added (current US$) of Least developed countries in 2010 to that in 2011?
Ensure brevity in your answer.  0.91. What is the ratio of the Value added (current US$) of Bolivia in 2010 to that in 2011?
Keep it short and to the point. 0.87. What is the ratio of the Value added (current US$) of Philippines in 2010 to that in 2011?
Make the answer very short. 0.86. What is the ratio of the Value added (current US$) in Heavily indebted poor countries in 2010 to that in 2012?
Ensure brevity in your answer.  0.82. What is the ratio of the Value added (current US$) of Least developed countries in 2010 to that in 2012?
Offer a terse response. 0.82. What is the ratio of the Value added (current US$) in Bolivia in 2010 to that in 2012?
Your answer should be compact. 0.77. What is the ratio of the Value added (current US$) in Philippines in 2010 to that in 2012?
Provide a succinct answer. 0.83. What is the ratio of the Value added (current US$) of Heavily indebted poor countries in 2010 to that in 2013?
Provide a succinct answer. 0.78. What is the ratio of the Value added (current US$) of Least developed countries in 2010 to that in 2013?
Provide a short and direct response. 0.79. What is the ratio of the Value added (current US$) of Bolivia in 2010 to that in 2013?
Give a very brief answer. 0.67. What is the ratio of the Value added (current US$) of Philippines in 2010 to that in 2013?
Your response must be concise. 0.8. What is the ratio of the Value added (current US$) in Heavily indebted poor countries in 2010 to that in 2014?
Offer a very short reply. 0.75. What is the ratio of the Value added (current US$) in Least developed countries in 2010 to that in 2014?
Your answer should be very brief. 0.73. What is the ratio of the Value added (current US$) of Bolivia in 2010 to that in 2014?
Ensure brevity in your answer.  0.64. What is the ratio of the Value added (current US$) of Philippines in 2010 to that in 2014?
Make the answer very short. 0.76. What is the ratio of the Value added (current US$) in Heavily indebted poor countries in 2011 to that in 2012?
Keep it short and to the point. 0.9. What is the ratio of the Value added (current US$) in Least developed countries in 2011 to that in 2012?
Provide a succinct answer. 0.9. What is the ratio of the Value added (current US$) of Bolivia in 2011 to that in 2012?
Your answer should be compact. 0.88. What is the ratio of the Value added (current US$) of Philippines in 2011 to that in 2012?
Your response must be concise. 0.96. What is the ratio of the Value added (current US$) of Least developed countries in 2011 to that in 2013?
Offer a very short reply. 0.86. What is the ratio of the Value added (current US$) of Bolivia in 2011 to that in 2013?
Give a very brief answer. 0.77. What is the ratio of the Value added (current US$) of Philippines in 2011 to that in 2013?
Make the answer very short. 0.93. What is the ratio of the Value added (current US$) in Heavily indebted poor countries in 2011 to that in 2014?
Give a very brief answer. 0.82. What is the ratio of the Value added (current US$) in Least developed countries in 2011 to that in 2014?
Offer a very short reply. 0.8. What is the ratio of the Value added (current US$) in Bolivia in 2011 to that in 2014?
Provide a succinct answer. 0.73. What is the ratio of the Value added (current US$) in Philippines in 2011 to that in 2014?
Make the answer very short. 0.89. What is the ratio of the Value added (current US$) in Heavily indebted poor countries in 2012 to that in 2013?
Offer a terse response. 0.95. What is the ratio of the Value added (current US$) of Least developed countries in 2012 to that in 2013?
Your response must be concise. 0.96. What is the ratio of the Value added (current US$) of Bolivia in 2012 to that in 2013?
Offer a very short reply. 0.87. What is the ratio of the Value added (current US$) in Philippines in 2012 to that in 2013?
Give a very brief answer. 0.97. What is the ratio of the Value added (current US$) of Heavily indebted poor countries in 2012 to that in 2014?
Your answer should be compact. 0.91. What is the ratio of the Value added (current US$) of Least developed countries in 2012 to that in 2014?
Give a very brief answer. 0.89. What is the ratio of the Value added (current US$) of Bolivia in 2012 to that in 2014?
Keep it short and to the point. 0.83. What is the ratio of the Value added (current US$) of Heavily indebted poor countries in 2013 to that in 2014?
Offer a terse response. 0.95. What is the ratio of the Value added (current US$) of Least developed countries in 2013 to that in 2014?
Provide a succinct answer. 0.93. What is the ratio of the Value added (current US$) in Bolivia in 2013 to that in 2014?
Give a very brief answer. 0.95. What is the difference between the highest and the second highest Value added (current US$) in Heavily indebted poor countries?
Provide a succinct answer. 7.17e+09. What is the difference between the highest and the second highest Value added (current US$) in Least developed countries?
Your answer should be compact. 1.34e+1. What is the difference between the highest and the second highest Value added (current US$) in Bolivia?
Offer a terse response. 1.58e+08. What is the difference between the highest and the second highest Value added (current US$) in Philippines?
Offer a very short reply. 1.61e+09. What is the difference between the highest and the lowest Value added (current US$) of Heavily indebted poor countries?
Keep it short and to the point. 4.58e+1. What is the difference between the highest and the lowest Value added (current US$) in Least developed countries?
Make the answer very short. 6.07e+1. What is the difference between the highest and the lowest Value added (current US$) of Bolivia?
Provide a short and direct response. 1.28e+09. What is the difference between the highest and the lowest Value added (current US$) in Philippines?
Keep it short and to the point. 1.01e+1. 